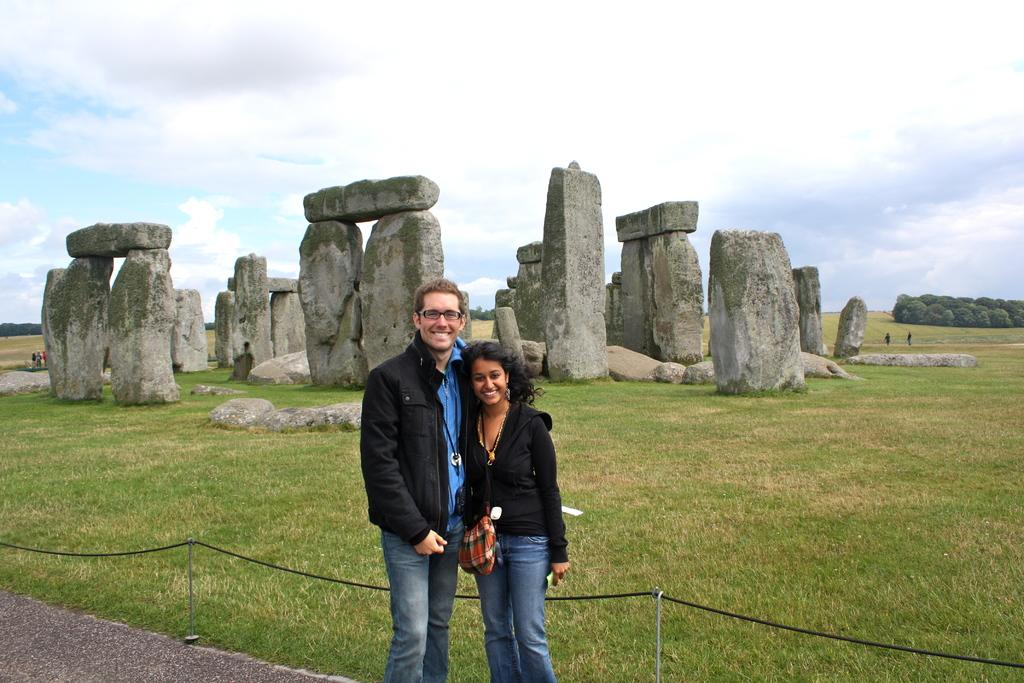What are the people in the image doing? The man and the woman in the image are standing and smiling. What type of natural environment is visible in the image? There are rocks, trees, and grass in the image. How many people are present in the image? There is a group of people standing in the image. What is visible in the background of the image? The sky is visible in the background of the image. What type of loaf is being carried by the man in the image? There is no loaf present in the image; the man is not carrying anything. What type of lumber is being used to construct the trees in the image? The trees in the image are natural, and therefore, there is no lumber involved in their construction. 